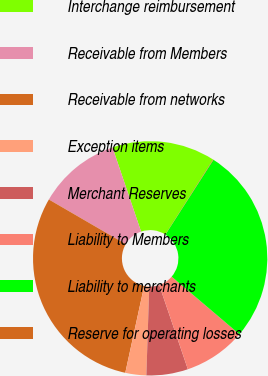<chart> <loc_0><loc_0><loc_500><loc_500><pie_chart><fcel>Interchange reimbursement<fcel>Receivable from Members<fcel>Receivable from networks<fcel>Exception items<fcel>Merchant Reserves<fcel>Liability to Members<fcel>Liability to merchants<fcel>Reserve for operating losses<nl><fcel>14.24%<fcel>11.41%<fcel>29.97%<fcel>2.89%<fcel>5.73%<fcel>8.57%<fcel>27.13%<fcel>0.06%<nl></chart> 